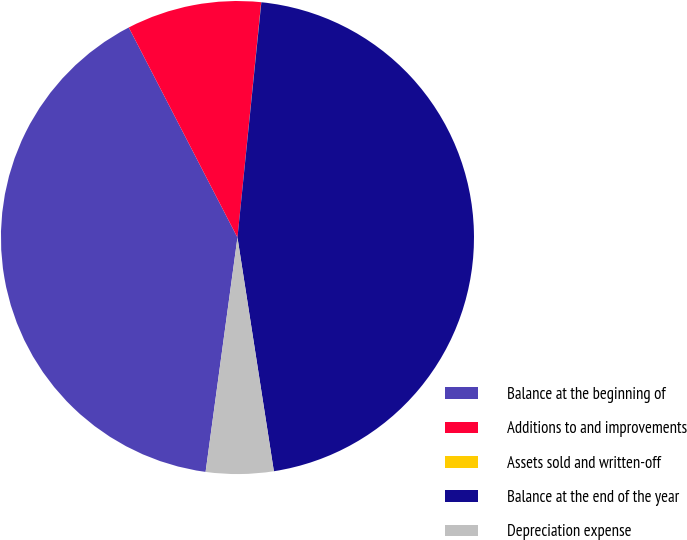<chart> <loc_0><loc_0><loc_500><loc_500><pie_chart><fcel>Balance at the beginning of<fcel>Additions to and improvements<fcel>Assets sold and written-off<fcel>Balance at the end of the year<fcel>Depreciation expense<nl><fcel>40.25%<fcel>9.2%<fcel>0.01%<fcel>45.93%<fcel>4.61%<nl></chart> 